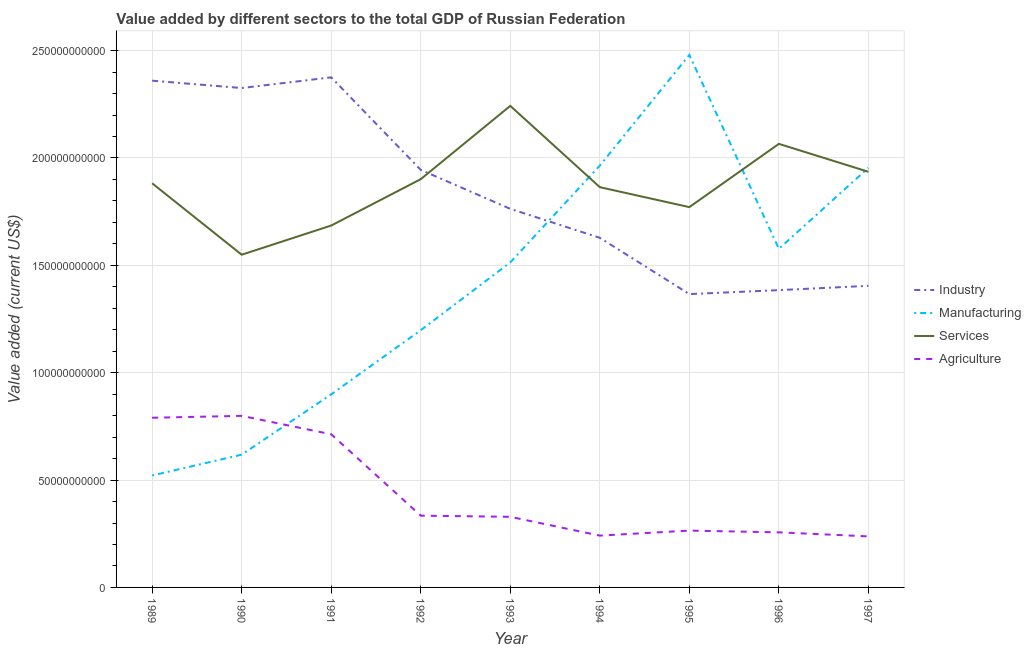Does the line corresponding to value added by services sector intersect with the line corresponding to value added by manufacturing sector?
Offer a terse response. Yes. Is the number of lines equal to the number of legend labels?
Keep it short and to the point. Yes. What is the value added by industrial sector in 1997?
Offer a terse response. 1.40e+11. Across all years, what is the maximum value added by industrial sector?
Your answer should be very brief. 2.38e+11. Across all years, what is the minimum value added by industrial sector?
Your answer should be very brief. 1.37e+11. In which year was the value added by services sector minimum?
Offer a terse response. 1990. What is the total value added by agricultural sector in the graph?
Provide a short and direct response. 3.97e+11. What is the difference between the value added by manufacturing sector in 1992 and that in 1997?
Offer a very short reply. -7.56e+1. What is the difference between the value added by agricultural sector in 1991 and the value added by manufacturing sector in 1994?
Your answer should be compact. -1.25e+11. What is the average value added by industrial sector per year?
Provide a short and direct response. 1.84e+11. In the year 1995, what is the difference between the value added by manufacturing sector and value added by agricultural sector?
Make the answer very short. 2.22e+11. In how many years, is the value added by services sector greater than 220000000000 US$?
Provide a succinct answer. 1. What is the ratio of the value added by manufacturing sector in 1989 to that in 1996?
Offer a terse response. 0.33. What is the difference between the highest and the second highest value added by industrial sector?
Keep it short and to the point. 1.55e+09. What is the difference between the highest and the lowest value added by agricultural sector?
Ensure brevity in your answer.  5.61e+1. Is it the case that in every year, the sum of the value added by agricultural sector and value added by services sector is greater than the sum of value added by manufacturing sector and value added by industrial sector?
Your answer should be very brief. No. Does the value added by industrial sector monotonically increase over the years?
Your response must be concise. No. Is the value added by manufacturing sector strictly less than the value added by agricultural sector over the years?
Give a very brief answer. No. How many lines are there?
Keep it short and to the point. 4. Are the values on the major ticks of Y-axis written in scientific E-notation?
Provide a succinct answer. No. Does the graph contain any zero values?
Keep it short and to the point. No. Where does the legend appear in the graph?
Provide a short and direct response. Center right. How many legend labels are there?
Make the answer very short. 4. How are the legend labels stacked?
Give a very brief answer. Vertical. What is the title of the graph?
Provide a short and direct response. Value added by different sectors to the total GDP of Russian Federation. What is the label or title of the X-axis?
Your answer should be very brief. Year. What is the label or title of the Y-axis?
Keep it short and to the point. Value added (current US$). What is the Value added (current US$) in Industry in 1989?
Provide a short and direct response. 2.36e+11. What is the Value added (current US$) in Manufacturing in 1989?
Keep it short and to the point. 5.21e+1. What is the Value added (current US$) of Services in 1989?
Provide a succinct answer. 1.88e+11. What is the Value added (current US$) in Agriculture in 1989?
Your answer should be compact. 7.90e+1. What is the Value added (current US$) in Industry in 1990?
Give a very brief answer. 2.33e+11. What is the Value added (current US$) of Manufacturing in 1990?
Your answer should be compact. 6.18e+1. What is the Value added (current US$) in Services in 1990?
Your response must be concise. 1.55e+11. What is the Value added (current US$) in Agriculture in 1990?
Give a very brief answer. 7.99e+1. What is the Value added (current US$) of Industry in 1991?
Offer a terse response. 2.38e+11. What is the Value added (current US$) in Manufacturing in 1991?
Your response must be concise. 8.99e+1. What is the Value added (current US$) in Services in 1991?
Keep it short and to the point. 1.69e+11. What is the Value added (current US$) in Agriculture in 1991?
Make the answer very short. 7.13e+1. What is the Value added (current US$) in Industry in 1992?
Ensure brevity in your answer.  1.94e+11. What is the Value added (current US$) in Manufacturing in 1992?
Your response must be concise. 1.20e+11. What is the Value added (current US$) of Services in 1992?
Offer a terse response. 1.90e+11. What is the Value added (current US$) of Agriculture in 1992?
Keep it short and to the point. 3.34e+1. What is the Value added (current US$) in Industry in 1993?
Your answer should be very brief. 1.76e+11. What is the Value added (current US$) of Manufacturing in 1993?
Keep it short and to the point. 1.51e+11. What is the Value added (current US$) of Services in 1993?
Your response must be concise. 2.24e+11. What is the Value added (current US$) of Agriculture in 1993?
Make the answer very short. 3.29e+1. What is the Value added (current US$) in Industry in 1994?
Your answer should be very brief. 1.63e+11. What is the Value added (current US$) of Manufacturing in 1994?
Provide a succinct answer. 1.96e+11. What is the Value added (current US$) of Services in 1994?
Provide a short and direct response. 1.86e+11. What is the Value added (current US$) of Agriculture in 1994?
Your answer should be compact. 2.41e+1. What is the Value added (current US$) in Industry in 1995?
Ensure brevity in your answer.  1.37e+11. What is the Value added (current US$) of Manufacturing in 1995?
Your answer should be very brief. 2.48e+11. What is the Value added (current US$) in Services in 1995?
Offer a very short reply. 1.77e+11. What is the Value added (current US$) of Agriculture in 1995?
Your response must be concise. 2.65e+1. What is the Value added (current US$) of Industry in 1996?
Your answer should be compact. 1.38e+11. What is the Value added (current US$) in Manufacturing in 1996?
Keep it short and to the point. 1.58e+11. What is the Value added (current US$) of Services in 1996?
Your answer should be very brief. 2.07e+11. What is the Value added (current US$) in Agriculture in 1996?
Give a very brief answer. 2.57e+1. What is the Value added (current US$) of Industry in 1997?
Offer a very short reply. 1.40e+11. What is the Value added (current US$) in Manufacturing in 1997?
Your answer should be compact. 1.95e+11. What is the Value added (current US$) in Services in 1997?
Give a very brief answer. 1.94e+11. What is the Value added (current US$) of Agriculture in 1997?
Offer a terse response. 2.38e+1. Across all years, what is the maximum Value added (current US$) in Industry?
Keep it short and to the point. 2.38e+11. Across all years, what is the maximum Value added (current US$) of Manufacturing?
Your answer should be very brief. 2.48e+11. Across all years, what is the maximum Value added (current US$) in Services?
Make the answer very short. 2.24e+11. Across all years, what is the maximum Value added (current US$) of Agriculture?
Offer a terse response. 7.99e+1. Across all years, what is the minimum Value added (current US$) in Industry?
Offer a very short reply. 1.37e+11. Across all years, what is the minimum Value added (current US$) in Manufacturing?
Provide a succinct answer. 5.21e+1. Across all years, what is the minimum Value added (current US$) of Services?
Offer a terse response. 1.55e+11. Across all years, what is the minimum Value added (current US$) in Agriculture?
Your answer should be compact. 2.38e+1. What is the total Value added (current US$) of Industry in the graph?
Give a very brief answer. 1.66e+12. What is the total Value added (current US$) of Manufacturing in the graph?
Provide a short and direct response. 1.27e+12. What is the total Value added (current US$) in Services in the graph?
Your answer should be very brief. 1.69e+12. What is the total Value added (current US$) in Agriculture in the graph?
Give a very brief answer. 3.97e+11. What is the difference between the Value added (current US$) of Industry in 1989 and that in 1990?
Make the answer very short. 3.43e+09. What is the difference between the Value added (current US$) in Manufacturing in 1989 and that in 1990?
Provide a short and direct response. -9.70e+09. What is the difference between the Value added (current US$) in Services in 1989 and that in 1990?
Give a very brief answer. 3.33e+1. What is the difference between the Value added (current US$) in Agriculture in 1989 and that in 1990?
Offer a terse response. -8.80e+08. What is the difference between the Value added (current US$) of Industry in 1989 and that in 1991?
Give a very brief answer. -1.55e+09. What is the difference between the Value added (current US$) of Manufacturing in 1989 and that in 1991?
Offer a terse response. -3.78e+1. What is the difference between the Value added (current US$) of Services in 1989 and that in 1991?
Offer a terse response. 1.97e+1. What is the difference between the Value added (current US$) in Agriculture in 1989 and that in 1991?
Ensure brevity in your answer.  7.69e+09. What is the difference between the Value added (current US$) in Industry in 1989 and that in 1992?
Your answer should be very brief. 4.15e+1. What is the difference between the Value added (current US$) in Manufacturing in 1989 and that in 1992?
Give a very brief answer. -6.77e+1. What is the difference between the Value added (current US$) of Services in 1989 and that in 1992?
Offer a terse response. -1.91e+09. What is the difference between the Value added (current US$) of Agriculture in 1989 and that in 1992?
Keep it short and to the point. 4.56e+1. What is the difference between the Value added (current US$) of Industry in 1989 and that in 1993?
Your response must be concise. 5.97e+1. What is the difference between the Value added (current US$) in Manufacturing in 1989 and that in 1993?
Keep it short and to the point. -9.92e+1. What is the difference between the Value added (current US$) of Services in 1989 and that in 1993?
Provide a succinct answer. -3.61e+1. What is the difference between the Value added (current US$) in Agriculture in 1989 and that in 1993?
Provide a short and direct response. 4.61e+1. What is the difference between the Value added (current US$) in Industry in 1989 and that in 1994?
Provide a succinct answer. 7.32e+1. What is the difference between the Value added (current US$) of Manufacturing in 1989 and that in 1994?
Offer a very short reply. -1.44e+11. What is the difference between the Value added (current US$) of Services in 1989 and that in 1994?
Give a very brief answer. 1.81e+09. What is the difference between the Value added (current US$) in Agriculture in 1989 and that in 1994?
Offer a terse response. 5.49e+1. What is the difference between the Value added (current US$) of Industry in 1989 and that in 1995?
Your answer should be very brief. 9.94e+1. What is the difference between the Value added (current US$) of Manufacturing in 1989 and that in 1995?
Provide a succinct answer. -1.96e+11. What is the difference between the Value added (current US$) in Services in 1989 and that in 1995?
Provide a short and direct response. 1.11e+1. What is the difference between the Value added (current US$) of Agriculture in 1989 and that in 1995?
Offer a terse response. 5.26e+1. What is the difference between the Value added (current US$) in Industry in 1989 and that in 1996?
Ensure brevity in your answer.  9.76e+1. What is the difference between the Value added (current US$) in Manufacturing in 1989 and that in 1996?
Provide a succinct answer. -1.06e+11. What is the difference between the Value added (current US$) in Services in 1989 and that in 1996?
Ensure brevity in your answer.  -1.84e+1. What is the difference between the Value added (current US$) of Agriculture in 1989 and that in 1996?
Your response must be concise. 5.34e+1. What is the difference between the Value added (current US$) of Industry in 1989 and that in 1997?
Your response must be concise. 9.55e+1. What is the difference between the Value added (current US$) in Manufacturing in 1989 and that in 1997?
Your answer should be very brief. -1.43e+11. What is the difference between the Value added (current US$) of Services in 1989 and that in 1997?
Your answer should be compact. -5.35e+09. What is the difference between the Value added (current US$) of Agriculture in 1989 and that in 1997?
Provide a succinct answer. 5.53e+1. What is the difference between the Value added (current US$) of Industry in 1990 and that in 1991?
Offer a very short reply. -4.98e+09. What is the difference between the Value added (current US$) in Manufacturing in 1990 and that in 1991?
Offer a terse response. -2.81e+1. What is the difference between the Value added (current US$) in Services in 1990 and that in 1991?
Offer a terse response. -1.36e+1. What is the difference between the Value added (current US$) of Agriculture in 1990 and that in 1991?
Keep it short and to the point. 8.57e+09. What is the difference between the Value added (current US$) in Industry in 1990 and that in 1992?
Make the answer very short. 3.81e+1. What is the difference between the Value added (current US$) in Manufacturing in 1990 and that in 1992?
Provide a short and direct response. -5.80e+1. What is the difference between the Value added (current US$) in Services in 1990 and that in 1992?
Make the answer very short. -3.52e+1. What is the difference between the Value added (current US$) of Agriculture in 1990 and that in 1992?
Ensure brevity in your answer.  4.65e+1. What is the difference between the Value added (current US$) in Industry in 1990 and that in 1993?
Make the answer very short. 5.63e+1. What is the difference between the Value added (current US$) in Manufacturing in 1990 and that in 1993?
Make the answer very short. -8.95e+1. What is the difference between the Value added (current US$) of Services in 1990 and that in 1993?
Make the answer very short. -6.93e+1. What is the difference between the Value added (current US$) in Agriculture in 1990 and that in 1993?
Keep it short and to the point. 4.70e+1. What is the difference between the Value added (current US$) of Industry in 1990 and that in 1994?
Make the answer very short. 6.98e+1. What is the difference between the Value added (current US$) of Manufacturing in 1990 and that in 1994?
Provide a succinct answer. -1.35e+11. What is the difference between the Value added (current US$) in Services in 1990 and that in 1994?
Provide a succinct answer. -3.15e+1. What is the difference between the Value added (current US$) of Agriculture in 1990 and that in 1994?
Your answer should be compact. 5.58e+1. What is the difference between the Value added (current US$) of Industry in 1990 and that in 1995?
Provide a succinct answer. 9.60e+1. What is the difference between the Value added (current US$) in Manufacturing in 1990 and that in 1995?
Give a very brief answer. -1.86e+11. What is the difference between the Value added (current US$) of Services in 1990 and that in 1995?
Make the answer very short. -2.22e+1. What is the difference between the Value added (current US$) of Agriculture in 1990 and that in 1995?
Your answer should be very brief. 5.34e+1. What is the difference between the Value added (current US$) in Industry in 1990 and that in 1996?
Make the answer very short. 9.41e+1. What is the difference between the Value added (current US$) in Manufacturing in 1990 and that in 1996?
Your answer should be compact. -9.59e+1. What is the difference between the Value added (current US$) of Services in 1990 and that in 1996?
Ensure brevity in your answer.  -5.16e+1. What is the difference between the Value added (current US$) of Agriculture in 1990 and that in 1996?
Your response must be concise. 5.42e+1. What is the difference between the Value added (current US$) in Industry in 1990 and that in 1997?
Your answer should be very brief. 9.21e+1. What is the difference between the Value added (current US$) in Manufacturing in 1990 and that in 1997?
Keep it short and to the point. -1.34e+11. What is the difference between the Value added (current US$) in Services in 1990 and that in 1997?
Your answer should be compact. -3.86e+1. What is the difference between the Value added (current US$) in Agriculture in 1990 and that in 1997?
Make the answer very short. 5.61e+1. What is the difference between the Value added (current US$) of Industry in 1991 and that in 1992?
Ensure brevity in your answer.  4.31e+1. What is the difference between the Value added (current US$) of Manufacturing in 1991 and that in 1992?
Ensure brevity in your answer.  -2.99e+1. What is the difference between the Value added (current US$) of Services in 1991 and that in 1992?
Offer a terse response. -2.16e+1. What is the difference between the Value added (current US$) in Agriculture in 1991 and that in 1992?
Provide a succinct answer. 3.79e+1. What is the difference between the Value added (current US$) of Industry in 1991 and that in 1993?
Offer a terse response. 6.12e+1. What is the difference between the Value added (current US$) in Manufacturing in 1991 and that in 1993?
Give a very brief answer. -6.14e+1. What is the difference between the Value added (current US$) of Services in 1991 and that in 1993?
Provide a short and direct response. -5.57e+1. What is the difference between the Value added (current US$) in Agriculture in 1991 and that in 1993?
Offer a terse response. 3.85e+1. What is the difference between the Value added (current US$) in Industry in 1991 and that in 1994?
Give a very brief answer. 7.47e+1. What is the difference between the Value added (current US$) of Manufacturing in 1991 and that in 1994?
Ensure brevity in your answer.  -1.07e+11. What is the difference between the Value added (current US$) of Services in 1991 and that in 1994?
Your response must be concise. -1.79e+1. What is the difference between the Value added (current US$) in Agriculture in 1991 and that in 1994?
Offer a terse response. 4.72e+1. What is the difference between the Value added (current US$) of Industry in 1991 and that in 1995?
Your answer should be very brief. 1.01e+11. What is the difference between the Value added (current US$) in Manufacturing in 1991 and that in 1995?
Your answer should be very brief. -1.58e+11. What is the difference between the Value added (current US$) of Services in 1991 and that in 1995?
Your answer should be compact. -8.58e+09. What is the difference between the Value added (current US$) in Agriculture in 1991 and that in 1995?
Provide a short and direct response. 4.49e+1. What is the difference between the Value added (current US$) in Industry in 1991 and that in 1996?
Your answer should be compact. 9.91e+1. What is the difference between the Value added (current US$) of Manufacturing in 1991 and that in 1996?
Make the answer very short. -6.78e+1. What is the difference between the Value added (current US$) in Services in 1991 and that in 1996?
Offer a very short reply. -3.80e+1. What is the difference between the Value added (current US$) of Agriculture in 1991 and that in 1996?
Offer a terse response. 4.57e+1. What is the difference between the Value added (current US$) in Industry in 1991 and that in 1997?
Keep it short and to the point. 9.71e+1. What is the difference between the Value added (current US$) in Manufacturing in 1991 and that in 1997?
Your answer should be very brief. -1.05e+11. What is the difference between the Value added (current US$) of Services in 1991 and that in 1997?
Your answer should be compact. -2.50e+1. What is the difference between the Value added (current US$) in Agriculture in 1991 and that in 1997?
Your answer should be very brief. 4.76e+1. What is the difference between the Value added (current US$) in Industry in 1992 and that in 1993?
Offer a very short reply. 1.82e+1. What is the difference between the Value added (current US$) in Manufacturing in 1992 and that in 1993?
Make the answer very short. -3.16e+1. What is the difference between the Value added (current US$) in Services in 1992 and that in 1993?
Give a very brief answer. -3.41e+1. What is the difference between the Value added (current US$) in Agriculture in 1992 and that in 1993?
Your answer should be compact. 5.52e+08. What is the difference between the Value added (current US$) of Industry in 1992 and that in 1994?
Your answer should be very brief. 3.16e+1. What is the difference between the Value added (current US$) of Manufacturing in 1992 and that in 1994?
Provide a short and direct response. -7.66e+1. What is the difference between the Value added (current US$) in Services in 1992 and that in 1994?
Offer a very short reply. 3.72e+09. What is the difference between the Value added (current US$) of Agriculture in 1992 and that in 1994?
Give a very brief answer. 9.30e+09. What is the difference between the Value added (current US$) in Industry in 1992 and that in 1995?
Provide a short and direct response. 5.79e+1. What is the difference between the Value added (current US$) of Manufacturing in 1992 and that in 1995?
Your answer should be very brief. -1.28e+11. What is the difference between the Value added (current US$) of Services in 1992 and that in 1995?
Offer a terse response. 1.30e+1. What is the difference between the Value added (current US$) of Agriculture in 1992 and that in 1995?
Ensure brevity in your answer.  6.96e+09. What is the difference between the Value added (current US$) of Industry in 1992 and that in 1996?
Ensure brevity in your answer.  5.60e+1. What is the difference between the Value added (current US$) of Manufacturing in 1992 and that in 1996?
Your response must be concise. -3.79e+1. What is the difference between the Value added (current US$) of Services in 1992 and that in 1996?
Your answer should be very brief. -1.64e+1. What is the difference between the Value added (current US$) of Agriculture in 1992 and that in 1996?
Make the answer very short. 7.78e+09. What is the difference between the Value added (current US$) in Industry in 1992 and that in 1997?
Your response must be concise. 5.40e+1. What is the difference between the Value added (current US$) of Manufacturing in 1992 and that in 1997?
Your answer should be very brief. -7.56e+1. What is the difference between the Value added (current US$) in Services in 1992 and that in 1997?
Offer a very short reply. -3.44e+09. What is the difference between the Value added (current US$) of Agriculture in 1992 and that in 1997?
Give a very brief answer. 9.66e+09. What is the difference between the Value added (current US$) in Industry in 1993 and that in 1994?
Your answer should be very brief. 1.35e+1. What is the difference between the Value added (current US$) of Manufacturing in 1993 and that in 1994?
Ensure brevity in your answer.  -4.51e+1. What is the difference between the Value added (current US$) of Services in 1993 and that in 1994?
Make the answer very short. 3.79e+1. What is the difference between the Value added (current US$) of Agriculture in 1993 and that in 1994?
Your response must be concise. 8.74e+09. What is the difference between the Value added (current US$) of Industry in 1993 and that in 1995?
Your answer should be very brief. 3.97e+1. What is the difference between the Value added (current US$) of Manufacturing in 1993 and that in 1995?
Keep it short and to the point. -9.66e+1. What is the difference between the Value added (current US$) in Services in 1993 and that in 1995?
Provide a succinct answer. 4.72e+1. What is the difference between the Value added (current US$) of Agriculture in 1993 and that in 1995?
Provide a short and direct response. 6.41e+09. What is the difference between the Value added (current US$) of Industry in 1993 and that in 1996?
Keep it short and to the point. 3.79e+1. What is the difference between the Value added (current US$) in Manufacturing in 1993 and that in 1996?
Offer a very short reply. -6.32e+09. What is the difference between the Value added (current US$) of Services in 1993 and that in 1996?
Your answer should be very brief. 1.77e+1. What is the difference between the Value added (current US$) of Agriculture in 1993 and that in 1996?
Ensure brevity in your answer.  7.22e+09. What is the difference between the Value added (current US$) of Industry in 1993 and that in 1997?
Provide a short and direct response. 3.59e+1. What is the difference between the Value added (current US$) of Manufacturing in 1993 and that in 1997?
Make the answer very short. -4.41e+1. What is the difference between the Value added (current US$) in Services in 1993 and that in 1997?
Provide a short and direct response. 3.07e+1. What is the difference between the Value added (current US$) in Agriculture in 1993 and that in 1997?
Your answer should be compact. 9.11e+09. What is the difference between the Value added (current US$) of Industry in 1994 and that in 1995?
Offer a terse response. 2.62e+1. What is the difference between the Value added (current US$) in Manufacturing in 1994 and that in 1995?
Provide a succinct answer. -5.16e+1. What is the difference between the Value added (current US$) in Services in 1994 and that in 1995?
Offer a terse response. 9.29e+09. What is the difference between the Value added (current US$) of Agriculture in 1994 and that in 1995?
Make the answer very short. -2.33e+09. What is the difference between the Value added (current US$) of Industry in 1994 and that in 1996?
Provide a short and direct response. 2.44e+1. What is the difference between the Value added (current US$) of Manufacturing in 1994 and that in 1996?
Provide a succinct answer. 3.87e+1. What is the difference between the Value added (current US$) in Services in 1994 and that in 1996?
Your answer should be very brief. -2.02e+1. What is the difference between the Value added (current US$) of Agriculture in 1994 and that in 1996?
Your answer should be compact. -1.52e+09. What is the difference between the Value added (current US$) in Industry in 1994 and that in 1997?
Offer a very short reply. 2.24e+1. What is the difference between the Value added (current US$) in Manufacturing in 1994 and that in 1997?
Provide a succinct answer. 1.02e+09. What is the difference between the Value added (current US$) of Services in 1994 and that in 1997?
Offer a terse response. -7.16e+09. What is the difference between the Value added (current US$) in Agriculture in 1994 and that in 1997?
Your answer should be very brief. 3.69e+08. What is the difference between the Value added (current US$) of Industry in 1995 and that in 1996?
Provide a succinct answer. -1.85e+09. What is the difference between the Value added (current US$) of Manufacturing in 1995 and that in 1996?
Provide a succinct answer. 9.03e+1. What is the difference between the Value added (current US$) in Services in 1995 and that in 1996?
Your response must be concise. -2.95e+1. What is the difference between the Value added (current US$) in Agriculture in 1995 and that in 1996?
Keep it short and to the point. 8.15e+08. What is the difference between the Value added (current US$) of Industry in 1995 and that in 1997?
Offer a very short reply. -3.85e+09. What is the difference between the Value added (current US$) of Manufacturing in 1995 and that in 1997?
Your response must be concise. 5.26e+1. What is the difference between the Value added (current US$) of Services in 1995 and that in 1997?
Offer a very short reply. -1.65e+1. What is the difference between the Value added (current US$) of Agriculture in 1995 and that in 1997?
Your answer should be compact. 2.70e+09. What is the difference between the Value added (current US$) of Industry in 1996 and that in 1997?
Ensure brevity in your answer.  -2.00e+09. What is the difference between the Value added (current US$) in Manufacturing in 1996 and that in 1997?
Provide a succinct answer. -3.77e+1. What is the difference between the Value added (current US$) of Services in 1996 and that in 1997?
Offer a terse response. 1.30e+1. What is the difference between the Value added (current US$) of Agriculture in 1996 and that in 1997?
Provide a short and direct response. 1.89e+09. What is the difference between the Value added (current US$) in Industry in 1989 and the Value added (current US$) in Manufacturing in 1990?
Make the answer very short. 1.74e+11. What is the difference between the Value added (current US$) in Industry in 1989 and the Value added (current US$) in Services in 1990?
Provide a short and direct response. 8.11e+1. What is the difference between the Value added (current US$) in Industry in 1989 and the Value added (current US$) in Agriculture in 1990?
Offer a terse response. 1.56e+11. What is the difference between the Value added (current US$) in Manufacturing in 1989 and the Value added (current US$) in Services in 1990?
Keep it short and to the point. -1.03e+11. What is the difference between the Value added (current US$) of Manufacturing in 1989 and the Value added (current US$) of Agriculture in 1990?
Provide a succinct answer. -2.78e+1. What is the difference between the Value added (current US$) in Services in 1989 and the Value added (current US$) in Agriculture in 1990?
Offer a very short reply. 1.08e+11. What is the difference between the Value added (current US$) in Industry in 1989 and the Value added (current US$) in Manufacturing in 1991?
Your answer should be compact. 1.46e+11. What is the difference between the Value added (current US$) of Industry in 1989 and the Value added (current US$) of Services in 1991?
Your answer should be compact. 6.75e+1. What is the difference between the Value added (current US$) in Industry in 1989 and the Value added (current US$) in Agriculture in 1991?
Make the answer very short. 1.65e+11. What is the difference between the Value added (current US$) of Manufacturing in 1989 and the Value added (current US$) of Services in 1991?
Your answer should be very brief. -1.16e+11. What is the difference between the Value added (current US$) in Manufacturing in 1989 and the Value added (current US$) in Agriculture in 1991?
Provide a short and direct response. -1.92e+1. What is the difference between the Value added (current US$) of Services in 1989 and the Value added (current US$) of Agriculture in 1991?
Offer a terse response. 1.17e+11. What is the difference between the Value added (current US$) in Industry in 1989 and the Value added (current US$) in Manufacturing in 1992?
Offer a terse response. 1.16e+11. What is the difference between the Value added (current US$) in Industry in 1989 and the Value added (current US$) in Services in 1992?
Offer a terse response. 4.59e+1. What is the difference between the Value added (current US$) of Industry in 1989 and the Value added (current US$) of Agriculture in 1992?
Give a very brief answer. 2.03e+11. What is the difference between the Value added (current US$) in Manufacturing in 1989 and the Value added (current US$) in Services in 1992?
Your answer should be very brief. -1.38e+11. What is the difference between the Value added (current US$) of Manufacturing in 1989 and the Value added (current US$) of Agriculture in 1992?
Your answer should be very brief. 1.87e+1. What is the difference between the Value added (current US$) of Services in 1989 and the Value added (current US$) of Agriculture in 1992?
Provide a short and direct response. 1.55e+11. What is the difference between the Value added (current US$) in Industry in 1989 and the Value added (current US$) in Manufacturing in 1993?
Your answer should be very brief. 8.46e+1. What is the difference between the Value added (current US$) of Industry in 1989 and the Value added (current US$) of Services in 1993?
Your answer should be compact. 1.17e+1. What is the difference between the Value added (current US$) in Industry in 1989 and the Value added (current US$) in Agriculture in 1993?
Offer a terse response. 2.03e+11. What is the difference between the Value added (current US$) of Manufacturing in 1989 and the Value added (current US$) of Services in 1993?
Your answer should be very brief. -1.72e+11. What is the difference between the Value added (current US$) in Manufacturing in 1989 and the Value added (current US$) in Agriculture in 1993?
Provide a succinct answer. 1.92e+1. What is the difference between the Value added (current US$) of Services in 1989 and the Value added (current US$) of Agriculture in 1993?
Your response must be concise. 1.55e+11. What is the difference between the Value added (current US$) of Industry in 1989 and the Value added (current US$) of Manufacturing in 1994?
Your answer should be very brief. 3.96e+1. What is the difference between the Value added (current US$) of Industry in 1989 and the Value added (current US$) of Services in 1994?
Your answer should be compact. 4.96e+1. What is the difference between the Value added (current US$) of Industry in 1989 and the Value added (current US$) of Agriculture in 1994?
Provide a short and direct response. 2.12e+11. What is the difference between the Value added (current US$) in Manufacturing in 1989 and the Value added (current US$) in Services in 1994?
Make the answer very short. -1.34e+11. What is the difference between the Value added (current US$) in Manufacturing in 1989 and the Value added (current US$) in Agriculture in 1994?
Provide a short and direct response. 2.80e+1. What is the difference between the Value added (current US$) of Services in 1989 and the Value added (current US$) of Agriculture in 1994?
Provide a short and direct response. 1.64e+11. What is the difference between the Value added (current US$) of Industry in 1989 and the Value added (current US$) of Manufacturing in 1995?
Provide a succinct answer. -1.20e+1. What is the difference between the Value added (current US$) of Industry in 1989 and the Value added (current US$) of Services in 1995?
Offer a very short reply. 5.89e+1. What is the difference between the Value added (current US$) of Industry in 1989 and the Value added (current US$) of Agriculture in 1995?
Make the answer very short. 2.10e+11. What is the difference between the Value added (current US$) in Manufacturing in 1989 and the Value added (current US$) in Services in 1995?
Provide a succinct answer. -1.25e+11. What is the difference between the Value added (current US$) in Manufacturing in 1989 and the Value added (current US$) in Agriculture in 1995?
Offer a very short reply. 2.57e+1. What is the difference between the Value added (current US$) of Services in 1989 and the Value added (current US$) of Agriculture in 1995?
Keep it short and to the point. 1.62e+11. What is the difference between the Value added (current US$) of Industry in 1989 and the Value added (current US$) of Manufacturing in 1996?
Give a very brief answer. 7.83e+1. What is the difference between the Value added (current US$) of Industry in 1989 and the Value added (current US$) of Services in 1996?
Your answer should be compact. 2.94e+1. What is the difference between the Value added (current US$) of Industry in 1989 and the Value added (current US$) of Agriculture in 1996?
Ensure brevity in your answer.  2.10e+11. What is the difference between the Value added (current US$) in Manufacturing in 1989 and the Value added (current US$) in Services in 1996?
Offer a terse response. -1.54e+11. What is the difference between the Value added (current US$) in Manufacturing in 1989 and the Value added (current US$) in Agriculture in 1996?
Offer a terse response. 2.65e+1. What is the difference between the Value added (current US$) in Services in 1989 and the Value added (current US$) in Agriculture in 1996?
Your response must be concise. 1.63e+11. What is the difference between the Value added (current US$) in Industry in 1989 and the Value added (current US$) in Manufacturing in 1997?
Ensure brevity in your answer.  4.06e+1. What is the difference between the Value added (current US$) in Industry in 1989 and the Value added (current US$) in Services in 1997?
Offer a very short reply. 4.24e+1. What is the difference between the Value added (current US$) of Industry in 1989 and the Value added (current US$) of Agriculture in 1997?
Provide a succinct answer. 2.12e+11. What is the difference between the Value added (current US$) in Manufacturing in 1989 and the Value added (current US$) in Services in 1997?
Your answer should be compact. -1.41e+11. What is the difference between the Value added (current US$) of Manufacturing in 1989 and the Value added (current US$) of Agriculture in 1997?
Provide a short and direct response. 2.84e+1. What is the difference between the Value added (current US$) of Services in 1989 and the Value added (current US$) of Agriculture in 1997?
Offer a terse response. 1.64e+11. What is the difference between the Value added (current US$) in Industry in 1990 and the Value added (current US$) in Manufacturing in 1991?
Give a very brief answer. 1.43e+11. What is the difference between the Value added (current US$) in Industry in 1990 and the Value added (current US$) in Services in 1991?
Ensure brevity in your answer.  6.40e+1. What is the difference between the Value added (current US$) in Industry in 1990 and the Value added (current US$) in Agriculture in 1991?
Provide a succinct answer. 1.61e+11. What is the difference between the Value added (current US$) of Manufacturing in 1990 and the Value added (current US$) of Services in 1991?
Ensure brevity in your answer.  -1.07e+11. What is the difference between the Value added (current US$) in Manufacturing in 1990 and the Value added (current US$) in Agriculture in 1991?
Your answer should be compact. -9.50e+09. What is the difference between the Value added (current US$) in Services in 1990 and the Value added (current US$) in Agriculture in 1991?
Your answer should be compact. 8.36e+1. What is the difference between the Value added (current US$) in Industry in 1990 and the Value added (current US$) in Manufacturing in 1992?
Provide a short and direct response. 1.13e+11. What is the difference between the Value added (current US$) of Industry in 1990 and the Value added (current US$) of Services in 1992?
Make the answer very short. 4.24e+1. What is the difference between the Value added (current US$) of Industry in 1990 and the Value added (current US$) of Agriculture in 1992?
Keep it short and to the point. 1.99e+11. What is the difference between the Value added (current US$) in Manufacturing in 1990 and the Value added (current US$) in Services in 1992?
Keep it short and to the point. -1.28e+11. What is the difference between the Value added (current US$) of Manufacturing in 1990 and the Value added (current US$) of Agriculture in 1992?
Make the answer very short. 2.84e+1. What is the difference between the Value added (current US$) of Services in 1990 and the Value added (current US$) of Agriculture in 1992?
Give a very brief answer. 1.22e+11. What is the difference between the Value added (current US$) of Industry in 1990 and the Value added (current US$) of Manufacturing in 1993?
Offer a terse response. 8.12e+1. What is the difference between the Value added (current US$) in Industry in 1990 and the Value added (current US$) in Services in 1993?
Ensure brevity in your answer.  8.31e+09. What is the difference between the Value added (current US$) of Industry in 1990 and the Value added (current US$) of Agriculture in 1993?
Your response must be concise. 2.00e+11. What is the difference between the Value added (current US$) of Manufacturing in 1990 and the Value added (current US$) of Services in 1993?
Ensure brevity in your answer.  -1.62e+11. What is the difference between the Value added (current US$) of Manufacturing in 1990 and the Value added (current US$) of Agriculture in 1993?
Your answer should be compact. 2.89e+1. What is the difference between the Value added (current US$) in Services in 1990 and the Value added (current US$) in Agriculture in 1993?
Your answer should be compact. 1.22e+11. What is the difference between the Value added (current US$) in Industry in 1990 and the Value added (current US$) in Manufacturing in 1994?
Give a very brief answer. 3.61e+1. What is the difference between the Value added (current US$) in Industry in 1990 and the Value added (current US$) in Services in 1994?
Make the answer very short. 4.62e+1. What is the difference between the Value added (current US$) of Industry in 1990 and the Value added (current US$) of Agriculture in 1994?
Make the answer very short. 2.08e+11. What is the difference between the Value added (current US$) of Manufacturing in 1990 and the Value added (current US$) of Services in 1994?
Your answer should be compact. -1.25e+11. What is the difference between the Value added (current US$) of Manufacturing in 1990 and the Value added (current US$) of Agriculture in 1994?
Your answer should be compact. 3.77e+1. What is the difference between the Value added (current US$) in Services in 1990 and the Value added (current US$) in Agriculture in 1994?
Your answer should be very brief. 1.31e+11. What is the difference between the Value added (current US$) of Industry in 1990 and the Value added (current US$) of Manufacturing in 1995?
Ensure brevity in your answer.  -1.54e+1. What is the difference between the Value added (current US$) of Industry in 1990 and the Value added (current US$) of Services in 1995?
Ensure brevity in your answer.  5.55e+1. What is the difference between the Value added (current US$) in Industry in 1990 and the Value added (current US$) in Agriculture in 1995?
Provide a succinct answer. 2.06e+11. What is the difference between the Value added (current US$) in Manufacturing in 1990 and the Value added (current US$) in Services in 1995?
Your answer should be very brief. -1.15e+11. What is the difference between the Value added (current US$) of Manufacturing in 1990 and the Value added (current US$) of Agriculture in 1995?
Offer a terse response. 3.54e+1. What is the difference between the Value added (current US$) in Services in 1990 and the Value added (current US$) in Agriculture in 1995?
Provide a succinct answer. 1.28e+11. What is the difference between the Value added (current US$) of Industry in 1990 and the Value added (current US$) of Manufacturing in 1996?
Offer a very short reply. 7.49e+1. What is the difference between the Value added (current US$) in Industry in 1990 and the Value added (current US$) in Services in 1996?
Keep it short and to the point. 2.60e+1. What is the difference between the Value added (current US$) in Industry in 1990 and the Value added (current US$) in Agriculture in 1996?
Keep it short and to the point. 2.07e+11. What is the difference between the Value added (current US$) of Manufacturing in 1990 and the Value added (current US$) of Services in 1996?
Give a very brief answer. -1.45e+11. What is the difference between the Value added (current US$) in Manufacturing in 1990 and the Value added (current US$) in Agriculture in 1996?
Provide a succinct answer. 3.62e+1. What is the difference between the Value added (current US$) of Services in 1990 and the Value added (current US$) of Agriculture in 1996?
Make the answer very short. 1.29e+11. What is the difference between the Value added (current US$) in Industry in 1990 and the Value added (current US$) in Manufacturing in 1997?
Your answer should be very brief. 3.72e+1. What is the difference between the Value added (current US$) of Industry in 1990 and the Value added (current US$) of Services in 1997?
Your response must be concise. 3.90e+1. What is the difference between the Value added (current US$) of Industry in 1990 and the Value added (current US$) of Agriculture in 1997?
Provide a succinct answer. 2.09e+11. What is the difference between the Value added (current US$) in Manufacturing in 1990 and the Value added (current US$) in Services in 1997?
Provide a short and direct response. -1.32e+11. What is the difference between the Value added (current US$) of Manufacturing in 1990 and the Value added (current US$) of Agriculture in 1997?
Give a very brief answer. 3.81e+1. What is the difference between the Value added (current US$) in Services in 1990 and the Value added (current US$) in Agriculture in 1997?
Ensure brevity in your answer.  1.31e+11. What is the difference between the Value added (current US$) of Industry in 1991 and the Value added (current US$) of Manufacturing in 1992?
Offer a terse response. 1.18e+11. What is the difference between the Value added (current US$) of Industry in 1991 and the Value added (current US$) of Services in 1992?
Provide a succinct answer. 4.74e+1. What is the difference between the Value added (current US$) of Industry in 1991 and the Value added (current US$) of Agriculture in 1992?
Provide a succinct answer. 2.04e+11. What is the difference between the Value added (current US$) in Manufacturing in 1991 and the Value added (current US$) in Services in 1992?
Keep it short and to the point. -1.00e+11. What is the difference between the Value added (current US$) of Manufacturing in 1991 and the Value added (current US$) of Agriculture in 1992?
Your response must be concise. 5.65e+1. What is the difference between the Value added (current US$) in Services in 1991 and the Value added (current US$) in Agriculture in 1992?
Offer a terse response. 1.35e+11. What is the difference between the Value added (current US$) of Industry in 1991 and the Value added (current US$) of Manufacturing in 1993?
Ensure brevity in your answer.  8.62e+1. What is the difference between the Value added (current US$) of Industry in 1991 and the Value added (current US$) of Services in 1993?
Offer a very short reply. 1.33e+1. What is the difference between the Value added (current US$) in Industry in 1991 and the Value added (current US$) in Agriculture in 1993?
Ensure brevity in your answer.  2.05e+11. What is the difference between the Value added (current US$) of Manufacturing in 1991 and the Value added (current US$) of Services in 1993?
Your answer should be very brief. -1.34e+11. What is the difference between the Value added (current US$) in Manufacturing in 1991 and the Value added (current US$) in Agriculture in 1993?
Give a very brief answer. 5.71e+1. What is the difference between the Value added (current US$) in Services in 1991 and the Value added (current US$) in Agriculture in 1993?
Offer a terse response. 1.36e+11. What is the difference between the Value added (current US$) in Industry in 1991 and the Value added (current US$) in Manufacturing in 1994?
Offer a very short reply. 4.11e+1. What is the difference between the Value added (current US$) in Industry in 1991 and the Value added (current US$) in Services in 1994?
Your answer should be compact. 5.11e+1. What is the difference between the Value added (current US$) in Industry in 1991 and the Value added (current US$) in Agriculture in 1994?
Your answer should be very brief. 2.13e+11. What is the difference between the Value added (current US$) of Manufacturing in 1991 and the Value added (current US$) of Services in 1994?
Provide a succinct answer. -9.65e+1. What is the difference between the Value added (current US$) of Manufacturing in 1991 and the Value added (current US$) of Agriculture in 1994?
Your answer should be very brief. 6.58e+1. What is the difference between the Value added (current US$) in Services in 1991 and the Value added (current US$) in Agriculture in 1994?
Ensure brevity in your answer.  1.44e+11. What is the difference between the Value added (current US$) of Industry in 1991 and the Value added (current US$) of Manufacturing in 1995?
Your response must be concise. -1.05e+1. What is the difference between the Value added (current US$) of Industry in 1991 and the Value added (current US$) of Services in 1995?
Provide a succinct answer. 6.04e+1. What is the difference between the Value added (current US$) in Industry in 1991 and the Value added (current US$) in Agriculture in 1995?
Your answer should be very brief. 2.11e+11. What is the difference between the Value added (current US$) in Manufacturing in 1991 and the Value added (current US$) in Services in 1995?
Your response must be concise. -8.72e+1. What is the difference between the Value added (current US$) of Manufacturing in 1991 and the Value added (current US$) of Agriculture in 1995?
Offer a terse response. 6.35e+1. What is the difference between the Value added (current US$) in Services in 1991 and the Value added (current US$) in Agriculture in 1995?
Give a very brief answer. 1.42e+11. What is the difference between the Value added (current US$) in Industry in 1991 and the Value added (current US$) in Manufacturing in 1996?
Ensure brevity in your answer.  7.99e+1. What is the difference between the Value added (current US$) in Industry in 1991 and the Value added (current US$) in Services in 1996?
Keep it short and to the point. 3.10e+1. What is the difference between the Value added (current US$) in Industry in 1991 and the Value added (current US$) in Agriculture in 1996?
Provide a short and direct response. 2.12e+11. What is the difference between the Value added (current US$) of Manufacturing in 1991 and the Value added (current US$) of Services in 1996?
Keep it short and to the point. -1.17e+11. What is the difference between the Value added (current US$) of Manufacturing in 1991 and the Value added (current US$) of Agriculture in 1996?
Your answer should be very brief. 6.43e+1. What is the difference between the Value added (current US$) in Services in 1991 and the Value added (current US$) in Agriculture in 1996?
Offer a terse response. 1.43e+11. What is the difference between the Value added (current US$) of Industry in 1991 and the Value added (current US$) of Manufacturing in 1997?
Give a very brief answer. 4.21e+1. What is the difference between the Value added (current US$) of Industry in 1991 and the Value added (current US$) of Services in 1997?
Keep it short and to the point. 4.40e+1. What is the difference between the Value added (current US$) in Industry in 1991 and the Value added (current US$) in Agriculture in 1997?
Ensure brevity in your answer.  2.14e+11. What is the difference between the Value added (current US$) in Manufacturing in 1991 and the Value added (current US$) in Services in 1997?
Your answer should be very brief. -1.04e+11. What is the difference between the Value added (current US$) in Manufacturing in 1991 and the Value added (current US$) in Agriculture in 1997?
Ensure brevity in your answer.  6.62e+1. What is the difference between the Value added (current US$) in Services in 1991 and the Value added (current US$) in Agriculture in 1997?
Your response must be concise. 1.45e+11. What is the difference between the Value added (current US$) of Industry in 1992 and the Value added (current US$) of Manufacturing in 1993?
Give a very brief answer. 4.31e+1. What is the difference between the Value added (current US$) in Industry in 1992 and the Value added (current US$) in Services in 1993?
Your response must be concise. -2.98e+1. What is the difference between the Value added (current US$) of Industry in 1992 and the Value added (current US$) of Agriculture in 1993?
Keep it short and to the point. 1.62e+11. What is the difference between the Value added (current US$) of Manufacturing in 1992 and the Value added (current US$) of Services in 1993?
Make the answer very short. -1.04e+11. What is the difference between the Value added (current US$) in Manufacturing in 1992 and the Value added (current US$) in Agriculture in 1993?
Keep it short and to the point. 8.69e+1. What is the difference between the Value added (current US$) of Services in 1992 and the Value added (current US$) of Agriculture in 1993?
Your response must be concise. 1.57e+11. What is the difference between the Value added (current US$) of Industry in 1992 and the Value added (current US$) of Manufacturing in 1994?
Keep it short and to the point. -1.97e+09. What is the difference between the Value added (current US$) in Industry in 1992 and the Value added (current US$) in Services in 1994?
Offer a very short reply. 8.06e+09. What is the difference between the Value added (current US$) in Industry in 1992 and the Value added (current US$) in Agriculture in 1994?
Provide a short and direct response. 1.70e+11. What is the difference between the Value added (current US$) in Manufacturing in 1992 and the Value added (current US$) in Services in 1994?
Offer a very short reply. -6.66e+1. What is the difference between the Value added (current US$) of Manufacturing in 1992 and the Value added (current US$) of Agriculture in 1994?
Make the answer very short. 9.57e+1. What is the difference between the Value added (current US$) in Services in 1992 and the Value added (current US$) in Agriculture in 1994?
Offer a terse response. 1.66e+11. What is the difference between the Value added (current US$) in Industry in 1992 and the Value added (current US$) in Manufacturing in 1995?
Provide a succinct answer. -5.35e+1. What is the difference between the Value added (current US$) in Industry in 1992 and the Value added (current US$) in Services in 1995?
Provide a succinct answer. 1.74e+1. What is the difference between the Value added (current US$) of Industry in 1992 and the Value added (current US$) of Agriculture in 1995?
Provide a short and direct response. 1.68e+11. What is the difference between the Value added (current US$) in Manufacturing in 1992 and the Value added (current US$) in Services in 1995?
Ensure brevity in your answer.  -5.73e+1. What is the difference between the Value added (current US$) of Manufacturing in 1992 and the Value added (current US$) of Agriculture in 1995?
Give a very brief answer. 9.33e+1. What is the difference between the Value added (current US$) in Services in 1992 and the Value added (current US$) in Agriculture in 1995?
Ensure brevity in your answer.  1.64e+11. What is the difference between the Value added (current US$) of Industry in 1992 and the Value added (current US$) of Manufacturing in 1996?
Keep it short and to the point. 3.68e+1. What is the difference between the Value added (current US$) in Industry in 1992 and the Value added (current US$) in Services in 1996?
Your response must be concise. -1.21e+1. What is the difference between the Value added (current US$) in Industry in 1992 and the Value added (current US$) in Agriculture in 1996?
Your answer should be compact. 1.69e+11. What is the difference between the Value added (current US$) in Manufacturing in 1992 and the Value added (current US$) in Services in 1996?
Provide a short and direct response. -8.68e+1. What is the difference between the Value added (current US$) in Manufacturing in 1992 and the Value added (current US$) in Agriculture in 1996?
Your answer should be compact. 9.41e+1. What is the difference between the Value added (current US$) in Services in 1992 and the Value added (current US$) in Agriculture in 1996?
Your response must be concise. 1.64e+11. What is the difference between the Value added (current US$) in Industry in 1992 and the Value added (current US$) in Manufacturing in 1997?
Offer a terse response. -9.51e+08. What is the difference between the Value added (current US$) of Industry in 1992 and the Value added (current US$) of Services in 1997?
Keep it short and to the point. 8.97e+08. What is the difference between the Value added (current US$) in Industry in 1992 and the Value added (current US$) in Agriculture in 1997?
Provide a succinct answer. 1.71e+11. What is the difference between the Value added (current US$) of Manufacturing in 1992 and the Value added (current US$) of Services in 1997?
Give a very brief answer. -7.38e+1. What is the difference between the Value added (current US$) of Manufacturing in 1992 and the Value added (current US$) of Agriculture in 1997?
Your answer should be very brief. 9.60e+1. What is the difference between the Value added (current US$) of Services in 1992 and the Value added (current US$) of Agriculture in 1997?
Provide a succinct answer. 1.66e+11. What is the difference between the Value added (current US$) of Industry in 1993 and the Value added (current US$) of Manufacturing in 1994?
Offer a terse response. -2.01e+1. What is the difference between the Value added (current US$) of Industry in 1993 and the Value added (current US$) of Services in 1994?
Keep it short and to the point. -1.01e+1. What is the difference between the Value added (current US$) in Industry in 1993 and the Value added (current US$) in Agriculture in 1994?
Provide a short and direct response. 1.52e+11. What is the difference between the Value added (current US$) in Manufacturing in 1993 and the Value added (current US$) in Services in 1994?
Offer a terse response. -3.50e+1. What is the difference between the Value added (current US$) in Manufacturing in 1993 and the Value added (current US$) in Agriculture in 1994?
Offer a very short reply. 1.27e+11. What is the difference between the Value added (current US$) in Services in 1993 and the Value added (current US$) in Agriculture in 1994?
Provide a succinct answer. 2.00e+11. What is the difference between the Value added (current US$) of Industry in 1993 and the Value added (current US$) of Manufacturing in 1995?
Offer a very short reply. -7.17e+1. What is the difference between the Value added (current US$) in Industry in 1993 and the Value added (current US$) in Services in 1995?
Provide a succinct answer. -8.04e+08. What is the difference between the Value added (current US$) of Industry in 1993 and the Value added (current US$) of Agriculture in 1995?
Provide a succinct answer. 1.50e+11. What is the difference between the Value added (current US$) of Manufacturing in 1993 and the Value added (current US$) of Services in 1995?
Provide a succinct answer. -2.58e+1. What is the difference between the Value added (current US$) of Manufacturing in 1993 and the Value added (current US$) of Agriculture in 1995?
Make the answer very short. 1.25e+11. What is the difference between the Value added (current US$) in Services in 1993 and the Value added (current US$) in Agriculture in 1995?
Your answer should be compact. 1.98e+11. What is the difference between the Value added (current US$) in Industry in 1993 and the Value added (current US$) in Manufacturing in 1996?
Give a very brief answer. 1.86e+1. What is the difference between the Value added (current US$) of Industry in 1993 and the Value added (current US$) of Services in 1996?
Give a very brief answer. -3.03e+1. What is the difference between the Value added (current US$) of Industry in 1993 and the Value added (current US$) of Agriculture in 1996?
Your answer should be compact. 1.51e+11. What is the difference between the Value added (current US$) of Manufacturing in 1993 and the Value added (current US$) of Services in 1996?
Offer a terse response. -5.52e+1. What is the difference between the Value added (current US$) of Manufacturing in 1993 and the Value added (current US$) of Agriculture in 1996?
Keep it short and to the point. 1.26e+11. What is the difference between the Value added (current US$) of Services in 1993 and the Value added (current US$) of Agriculture in 1996?
Give a very brief answer. 1.99e+11. What is the difference between the Value added (current US$) of Industry in 1993 and the Value added (current US$) of Manufacturing in 1997?
Offer a very short reply. -1.91e+1. What is the difference between the Value added (current US$) of Industry in 1993 and the Value added (current US$) of Services in 1997?
Your answer should be very brief. -1.73e+1. What is the difference between the Value added (current US$) in Industry in 1993 and the Value added (current US$) in Agriculture in 1997?
Your answer should be compact. 1.53e+11. What is the difference between the Value added (current US$) in Manufacturing in 1993 and the Value added (current US$) in Services in 1997?
Provide a succinct answer. -4.22e+1. What is the difference between the Value added (current US$) in Manufacturing in 1993 and the Value added (current US$) in Agriculture in 1997?
Make the answer very short. 1.28e+11. What is the difference between the Value added (current US$) of Services in 1993 and the Value added (current US$) of Agriculture in 1997?
Provide a short and direct response. 2.01e+11. What is the difference between the Value added (current US$) in Industry in 1994 and the Value added (current US$) in Manufacturing in 1995?
Give a very brief answer. -8.52e+1. What is the difference between the Value added (current US$) in Industry in 1994 and the Value added (current US$) in Services in 1995?
Your response must be concise. -1.43e+1. What is the difference between the Value added (current US$) of Industry in 1994 and the Value added (current US$) of Agriculture in 1995?
Your answer should be compact. 1.36e+11. What is the difference between the Value added (current US$) in Manufacturing in 1994 and the Value added (current US$) in Services in 1995?
Provide a short and direct response. 1.93e+1. What is the difference between the Value added (current US$) in Manufacturing in 1994 and the Value added (current US$) in Agriculture in 1995?
Ensure brevity in your answer.  1.70e+11. What is the difference between the Value added (current US$) of Services in 1994 and the Value added (current US$) of Agriculture in 1995?
Ensure brevity in your answer.  1.60e+11. What is the difference between the Value added (current US$) in Industry in 1994 and the Value added (current US$) in Manufacturing in 1996?
Provide a succinct answer. 5.14e+09. What is the difference between the Value added (current US$) of Industry in 1994 and the Value added (current US$) of Services in 1996?
Your answer should be very brief. -4.38e+1. What is the difference between the Value added (current US$) of Industry in 1994 and the Value added (current US$) of Agriculture in 1996?
Give a very brief answer. 1.37e+11. What is the difference between the Value added (current US$) in Manufacturing in 1994 and the Value added (current US$) in Services in 1996?
Your response must be concise. -1.01e+1. What is the difference between the Value added (current US$) of Manufacturing in 1994 and the Value added (current US$) of Agriculture in 1996?
Your answer should be very brief. 1.71e+11. What is the difference between the Value added (current US$) in Services in 1994 and the Value added (current US$) in Agriculture in 1996?
Give a very brief answer. 1.61e+11. What is the difference between the Value added (current US$) in Industry in 1994 and the Value added (current US$) in Manufacturing in 1997?
Your response must be concise. -3.26e+1. What is the difference between the Value added (current US$) of Industry in 1994 and the Value added (current US$) of Services in 1997?
Offer a very short reply. -3.07e+1. What is the difference between the Value added (current US$) of Industry in 1994 and the Value added (current US$) of Agriculture in 1997?
Ensure brevity in your answer.  1.39e+11. What is the difference between the Value added (current US$) of Manufacturing in 1994 and the Value added (current US$) of Services in 1997?
Provide a succinct answer. 2.87e+09. What is the difference between the Value added (current US$) of Manufacturing in 1994 and the Value added (current US$) of Agriculture in 1997?
Offer a very short reply. 1.73e+11. What is the difference between the Value added (current US$) in Services in 1994 and the Value added (current US$) in Agriculture in 1997?
Offer a very short reply. 1.63e+11. What is the difference between the Value added (current US$) of Industry in 1995 and the Value added (current US$) of Manufacturing in 1996?
Ensure brevity in your answer.  -2.11e+1. What is the difference between the Value added (current US$) of Industry in 1995 and the Value added (current US$) of Services in 1996?
Your answer should be compact. -7.00e+1. What is the difference between the Value added (current US$) of Industry in 1995 and the Value added (current US$) of Agriculture in 1996?
Offer a terse response. 1.11e+11. What is the difference between the Value added (current US$) of Manufacturing in 1995 and the Value added (current US$) of Services in 1996?
Make the answer very short. 4.14e+1. What is the difference between the Value added (current US$) of Manufacturing in 1995 and the Value added (current US$) of Agriculture in 1996?
Your response must be concise. 2.22e+11. What is the difference between the Value added (current US$) in Services in 1995 and the Value added (current US$) in Agriculture in 1996?
Offer a very short reply. 1.51e+11. What is the difference between the Value added (current US$) in Industry in 1995 and the Value added (current US$) in Manufacturing in 1997?
Keep it short and to the point. -5.88e+1. What is the difference between the Value added (current US$) of Industry in 1995 and the Value added (current US$) of Services in 1997?
Provide a short and direct response. -5.70e+1. What is the difference between the Value added (current US$) in Industry in 1995 and the Value added (current US$) in Agriculture in 1997?
Provide a short and direct response. 1.13e+11. What is the difference between the Value added (current US$) of Manufacturing in 1995 and the Value added (current US$) of Services in 1997?
Make the answer very short. 5.44e+1. What is the difference between the Value added (current US$) in Manufacturing in 1995 and the Value added (current US$) in Agriculture in 1997?
Your answer should be very brief. 2.24e+11. What is the difference between the Value added (current US$) in Services in 1995 and the Value added (current US$) in Agriculture in 1997?
Offer a terse response. 1.53e+11. What is the difference between the Value added (current US$) of Industry in 1996 and the Value added (current US$) of Manufacturing in 1997?
Your response must be concise. -5.70e+1. What is the difference between the Value added (current US$) in Industry in 1996 and the Value added (current US$) in Services in 1997?
Offer a very short reply. -5.51e+1. What is the difference between the Value added (current US$) in Industry in 1996 and the Value added (current US$) in Agriculture in 1997?
Give a very brief answer. 1.15e+11. What is the difference between the Value added (current US$) of Manufacturing in 1996 and the Value added (current US$) of Services in 1997?
Your answer should be very brief. -3.59e+1. What is the difference between the Value added (current US$) of Manufacturing in 1996 and the Value added (current US$) of Agriculture in 1997?
Provide a succinct answer. 1.34e+11. What is the difference between the Value added (current US$) in Services in 1996 and the Value added (current US$) in Agriculture in 1997?
Your response must be concise. 1.83e+11. What is the average Value added (current US$) in Industry per year?
Provide a succinct answer. 1.84e+11. What is the average Value added (current US$) in Manufacturing per year?
Make the answer very short. 1.41e+11. What is the average Value added (current US$) in Services per year?
Provide a short and direct response. 1.88e+11. What is the average Value added (current US$) of Agriculture per year?
Keep it short and to the point. 4.41e+1. In the year 1989, what is the difference between the Value added (current US$) in Industry and Value added (current US$) in Manufacturing?
Your response must be concise. 1.84e+11. In the year 1989, what is the difference between the Value added (current US$) of Industry and Value added (current US$) of Services?
Your answer should be compact. 4.78e+1. In the year 1989, what is the difference between the Value added (current US$) of Industry and Value added (current US$) of Agriculture?
Your answer should be very brief. 1.57e+11. In the year 1989, what is the difference between the Value added (current US$) of Manufacturing and Value added (current US$) of Services?
Ensure brevity in your answer.  -1.36e+11. In the year 1989, what is the difference between the Value added (current US$) of Manufacturing and Value added (current US$) of Agriculture?
Provide a succinct answer. -2.69e+1. In the year 1989, what is the difference between the Value added (current US$) of Services and Value added (current US$) of Agriculture?
Make the answer very short. 1.09e+11. In the year 1990, what is the difference between the Value added (current US$) of Industry and Value added (current US$) of Manufacturing?
Provide a short and direct response. 1.71e+11. In the year 1990, what is the difference between the Value added (current US$) in Industry and Value added (current US$) in Services?
Give a very brief answer. 7.76e+1. In the year 1990, what is the difference between the Value added (current US$) of Industry and Value added (current US$) of Agriculture?
Your answer should be very brief. 1.53e+11. In the year 1990, what is the difference between the Value added (current US$) in Manufacturing and Value added (current US$) in Services?
Give a very brief answer. -9.31e+1. In the year 1990, what is the difference between the Value added (current US$) in Manufacturing and Value added (current US$) in Agriculture?
Keep it short and to the point. -1.81e+1. In the year 1990, what is the difference between the Value added (current US$) in Services and Value added (current US$) in Agriculture?
Give a very brief answer. 7.51e+1. In the year 1991, what is the difference between the Value added (current US$) of Industry and Value added (current US$) of Manufacturing?
Make the answer very short. 1.48e+11. In the year 1991, what is the difference between the Value added (current US$) of Industry and Value added (current US$) of Services?
Offer a terse response. 6.90e+1. In the year 1991, what is the difference between the Value added (current US$) in Industry and Value added (current US$) in Agriculture?
Your answer should be compact. 1.66e+11. In the year 1991, what is the difference between the Value added (current US$) in Manufacturing and Value added (current US$) in Services?
Your answer should be very brief. -7.86e+1. In the year 1991, what is the difference between the Value added (current US$) in Manufacturing and Value added (current US$) in Agriculture?
Offer a terse response. 1.86e+1. In the year 1991, what is the difference between the Value added (current US$) of Services and Value added (current US$) of Agriculture?
Keep it short and to the point. 9.72e+1. In the year 1992, what is the difference between the Value added (current US$) in Industry and Value added (current US$) in Manufacturing?
Offer a very short reply. 7.47e+1. In the year 1992, what is the difference between the Value added (current US$) of Industry and Value added (current US$) of Services?
Offer a terse response. 4.33e+09. In the year 1992, what is the difference between the Value added (current US$) of Industry and Value added (current US$) of Agriculture?
Your answer should be compact. 1.61e+11. In the year 1992, what is the difference between the Value added (current US$) in Manufacturing and Value added (current US$) in Services?
Offer a terse response. -7.03e+1. In the year 1992, what is the difference between the Value added (current US$) of Manufacturing and Value added (current US$) of Agriculture?
Keep it short and to the point. 8.64e+1. In the year 1992, what is the difference between the Value added (current US$) in Services and Value added (current US$) in Agriculture?
Your response must be concise. 1.57e+11. In the year 1993, what is the difference between the Value added (current US$) of Industry and Value added (current US$) of Manufacturing?
Your answer should be compact. 2.49e+1. In the year 1993, what is the difference between the Value added (current US$) in Industry and Value added (current US$) in Services?
Provide a succinct answer. -4.80e+1. In the year 1993, what is the difference between the Value added (current US$) in Industry and Value added (current US$) in Agriculture?
Provide a succinct answer. 1.43e+11. In the year 1993, what is the difference between the Value added (current US$) of Manufacturing and Value added (current US$) of Services?
Your answer should be compact. -7.29e+1. In the year 1993, what is the difference between the Value added (current US$) in Manufacturing and Value added (current US$) in Agriculture?
Provide a short and direct response. 1.18e+11. In the year 1993, what is the difference between the Value added (current US$) in Services and Value added (current US$) in Agriculture?
Your response must be concise. 1.91e+11. In the year 1994, what is the difference between the Value added (current US$) of Industry and Value added (current US$) of Manufacturing?
Provide a succinct answer. -3.36e+1. In the year 1994, what is the difference between the Value added (current US$) of Industry and Value added (current US$) of Services?
Give a very brief answer. -2.36e+1. In the year 1994, what is the difference between the Value added (current US$) of Industry and Value added (current US$) of Agriculture?
Give a very brief answer. 1.39e+11. In the year 1994, what is the difference between the Value added (current US$) in Manufacturing and Value added (current US$) in Services?
Ensure brevity in your answer.  1.00e+1. In the year 1994, what is the difference between the Value added (current US$) in Manufacturing and Value added (current US$) in Agriculture?
Your answer should be very brief. 1.72e+11. In the year 1994, what is the difference between the Value added (current US$) of Services and Value added (current US$) of Agriculture?
Provide a succinct answer. 1.62e+11. In the year 1995, what is the difference between the Value added (current US$) in Industry and Value added (current US$) in Manufacturing?
Your answer should be compact. -1.11e+11. In the year 1995, what is the difference between the Value added (current US$) of Industry and Value added (current US$) of Services?
Your answer should be compact. -4.05e+1. In the year 1995, what is the difference between the Value added (current US$) in Industry and Value added (current US$) in Agriculture?
Offer a very short reply. 1.10e+11. In the year 1995, what is the difference between the Value added (current US$) of Manufacturing and Value added (current US$) of Services?
Your response must be concise. 7.09e+1. In the year 1995, what is the difference between the Value added (current US$) in Manufacturing and Value added (current US$) in Agriculture?
Your response must be concise. 2.22e+11. In the year 1995, what is the difference between the Value added (current US$) in Services and Value added (current US$) in Agriculture?
Keep it short and to the point. 1.51e+11. In the year 1996, what is the difference between the Value added (current US$) of Industry and Value added (current US$) of Manufacturing?
Provide a succinct answer. -1.92e+1. In the year 1996, what is the difference between the Value added (current US$) of Industry and Value added (current US$) of Services?
Keep it short and to the point. -6.81e+1. In the year 1996, what is the difference between the Value added (current US$) in Industry and Value added (current US$) in Agriculture?
Keep it short and to the point. 1.13e+11. In the year 1996, what is the difference between the Value added (current US$) of Manufacturing and Value added (current US$) of Services?
Provide a short and direct response. -4.89e+1. In the year 1996, what is the difference between the Value added (current US$) in Manufacturing and Value added (current US$) in Agriculture?
Provide a short and direct response. 1.32e+11. In the year 1996, what is the difference between the Value added (current US$) in Services and Value added (current US$) in Agriculture?
Keep it short and to the point. 1.81e+11. In the year 1997, what is the difference between the Value added (current US$) of Industry and Value added (current US$) of Manufacturing?
Offer a very short reply. -5.50e+1. In the year 1997, what is the difference between the Value added (current US$) of Industry and Value added (current US$) of Services?
Keep it short and to the point. -5.31e+1. In the year 1997, what is the difference between the Value added (current US$) of Industry and Value added (current US$) of Agriculture?
Provide a succinct answer. 1.17e+11. In the year 1997, what is the difference between the Value added (current US$) of Manufacturing and Value added (current US$) of Services?
Keep it short and to the point. 1.85e+09. In the year 1997, what is the difference between the Value added (current US$) of Manufacturing and Value added (current US$) of Agriculture?
Provide a succinct answer. 1.72e+11. In the year 1997, what is the difference between the Value added (current US$) in Services and Value added (current US$) in Agriculture?
Provide a succinct answer. 1.70e+11. What is the ratio of the Value added (current US$) in Industry in 1989 to that in 1990?
Make the answer very short. 1.01. What is the ratio of the Value added (current US$) of Manufacturing in 1989 to that in 1990?
Give a very brief answer. 0.84. What is the ratio of the Value added (current US$) in Services in 1989 to that in 1990?
Make the answer very short. 1.21. What is the ratio of the Value added (current US$) in Agriculture in 1989 to that in 1990?
Offer a very short reply. 0.99. What is the ratio of the Value added (current US$) of Manufacturing in 1989 to that in 1991?
Provide a succinct answer. 0.58. What is the ratio of the Value added (current US$) of Services in 1989 to that in 1991?
Provide a succinct answer. 1.12. What is the ratio of the Value added (current US$) in Agriculture in 1989 to that in 1991?
Your answer should be very brief. 1.11. What is the ratio of the Value added (current US$) of Industry in 1989 to that in 1992?
Ensure brevity in your answer.  1.21. What is the ratio of the Value added (current US$) of Manufacturing in 1989 to that in 1992?
Give a very brief answer. 0.44. What is the ratio of the Value added (current US$) in Agriculture in 1989 to that in 1992?
Make the answer very short. 2.36. What is the ratio of the Value added (current US$) in Industry in 1989 to that in 1993?
Offer a very short reply. 1.34. What is the ratio of the Value added (current US$) of Manufacturing in 1989 to that in 1993?
Provide a succinct answer. 0.34. What is the ratio of the Value added (current US$) in Services in 1989 to that in 1993?
Give a very brief answer. 0.84. What is the ratio of the Value added (current US$) in Agriculture in 1989 to that in 1993?
Your response must be concise. 2.4. What is the ratio of the Value added (current US$) in Industry in 1989 to that in 1994?
Provide a short and direct response. 1.45. What is the ratio of the Value added (current US$) in Manufacturing in 1989 to that in 1994?
Your answer should be very brief. 0.27. What is the ratio of the Value added (current US$) of Services in 1989 to that in 1994?
Provide a short and direct response. 1.01. What is the ratio of the Value added (current US$) of Agriculture in 1989 to that in 1994?
Ensure brevity in your answer.  3.27. What is the ratio of the Value added (current US$) of Industry in 1989 to that in 1995?
Your answer should be compact. 1.73. What is the ratio of the Value added (current US$) in Manufacturing in 1989 to that in 1995?
Offer a terse response. 0.21. What is the ratio of the Value added (current US$) of Services in 1989 to that in 1995?
Your answer should be compact. 1.06. What is the ratio of the Value added (current US$) of Agriculture in 1989 to that in 1995?
Ensure brevity in your answer.  2.99. What is the ratio of the Value added (current US$) of Industry in 1989 to that in 1996?
Offer a very short reply. 1.7. What is the ratio of the Value added (current US$) of Manufacturing in 1989 to that in 1996?
Give a very brief answer. 0.33. What is the ratio of the Value added (current US$) in Services in 1989 to that in 1996?
Your answer should be very brief. 0.91. What is the ratio of the Value added (current US$) in Agriculture in 1989 to that in 1996?
Give a very brief answer. 3.08. What is the ratio of the Value added (current US$) of Industry in 1989 to that in 1997?
Your answer should be compact. 1.68. What is the ratio of the Value added (current US$) of Manufacturing in 1989 to that in 1997?
Give a very brief answer. 0.27. What is the ratio of the Value added (current US$) of Services in 1989 to that in 1997?
Your response must be concise. 0.97. What is the ratio of the Value added (current US$) of Agriculture in 1989 to that in 1997?
Make the answer very short. 3.32. What is the ratio of the Value added (current US$) of Manufacturing in 1990 to that in 1991?
Your answer should be very brief. 0.69. What is the ratio of the Value added (current US$) in Services in 1990 to that in 1991?
Your response must be concise. 0.92. What is the ratio of the Value added (current US$) in Agriculture in 1990 to that in 1991?
Offer a terse response. 1.12. What is the ratio of the Value added (current US$) in Industry in 1990 to that in 1992?
Your answer should be very brief. 1.2. What is the ratio of the Value added (current US$) in Manufacturing in 1990 to that in 1992?
Give a very brief answer. 0.52. What is the ratio of the Value added (current US$) of Services in 1990 to that in 1992?
Your answer should be very brief. 0.81. What is the ratio of the Value added (current US$) in Agriculture in 1990 to that in 1992?
Keep it short and to the point. 2.39. What is the ratio of the Value added (current US$) of Industry in 1990 to that in 1993?
Provide a succinct answer. 1.32. What is the ratio of the Value added (current US$) of Manufacturing in 1990 to that in 1993?
Keep it short and to the point. 0.41. What is the ratio of the Value added (current US$) in Services in 1990 to that in 1993?
Ensure brevity in your answer.  0.69. What is the ratio of the Value added (current US$) of Agriculture in 1990 to that in 1993?
Make the answer very short. 2.43. What is the ratio of the Value added (current US$) of Industry in 1990 to that in 1994?
Make the answer very short. 1.43. What is the ratio of the Value added (current US$) in Manufacturing in 1990 to that in 1994?
Your answer should be compact. 0.31. What is the ratio of the Value added (current US$) in Services in 1990 to that in 1994?
Your response must be concise. 0.83. What is the ratio of the Value added (current US$) of Agriculture in 1990 to that in 1994?
Give a very brief answer. 3.31. What is the ratio of the Value added (current US$) of Industry in 1990 to that in 1995?
Give a very brief answer. 1.7. What is the ratio of the Value added (current US$) of Manufacturing in 1990 to that in 1995?
Offer a very short reply. 0.25. What is the ratio of the Value added (current US$) of Services in 1990 to that in 1995?
Ensure brevity in your answer.  0.87. What is the ratio of the Value added (current US$) of Agriculture in 1990 to that in 1995?
Keep it short and to the point. 3.02. What is the ratio of the Value added (current US$) of Industry in 1990 to that in 1996?
Your response must be concise. 1.68. What is the ratio of the Value added (current US$) of Manufacturing in 1990 to that in 1996?
Offer a very short reply. 0.39. What is the ratio of the Value added (current US$) in Services in 1990 to that in 1996?
Ensure brevity in your answer.  0.75. What is the ratio of the Value added (current US$) of Agriculture in 1990 to that in 1996?
Give a very brief answer. 3.11. What is the ratio of the Value added (current US$) in Industry in 1990 to that in 1997?
Your answer should be compact. 1.66. What is the ratio of the Value added (current US$) of Manufacturing in 1990 to that in 1997?
Provide a short and direct response. 0.32. What is the ratio of the Value added (current US$) of Services in 1990 to that in 1997?
Keep it short and to the point. 0.8. What is the ratio of the Value added (current US$) of Agriculture in 1990 to that in 1997?
Make the answer very short. 3.36. What is the ratio of the Value added (current US$) in Industry in 1991 to that in 1992?
Make the answer very short. 1.22. What is the ratio of the Value added (current US$) of Manufacturing in 1991 to that in 1992?
Offer a very short reply. 0.75. What is the ratio of the Value added (current US$) of Services in 1991 to that in 1992?
Keep it short and to the point. 0.89. What is the ratio of the Value added (current US$) of Agriculture in 1991 to that in 1992?
Provide a succinct answer. 2.13. What is the ratio of the Value added (current US$) of Industry in 1991 to that in 1993?
Your answer should be very brief. 1.35. What is the ratio of the Value added (current US$) in Manufacturing in 1991 to that in 1993?
Offer a very short reply. 0.59. What is the ratio of the Value added (current US$) in Services in 1991 to that in 1993?
Your response must be concise. 0.75. What is the ratio of the Value added (current US$) of Agriculture in 1991 to that in 1993?
Your answer should be compact. 2.17. What is the ratio of the Value added (current US$) in Industry in 1991 to that in 1994?
Keep it short and to the point. 1.46. What is the ratio of the Value added (current US$) of Manufacturing in 1991 to that in 1994?
Give a very brief answer. 0.46. What is the ratio of the Value added (current US$) of Services in 1991 to that in 1994?
Make the answer very short. 0.9. What is the ratio of the Value added (current US$) of Agriculture in 1991 to that in 1994?
Offer a very short reply. 2.96. What is the ratio of the Value added (current US$) of Industry in 1991 to that in 1995?
Keep it short and to the point. 1.74. What is the ratio of the Value added (current US$) in Manufacturing in 1991 to that in 1995?
Offer a very short reply. 0.36. What is the ratio of the Value added (current US$) of Services in 1991 to that in 1995?
Your answer should be compact. 0.95. What is the ratio of the Value added (current US$) of Agriculture in 1991 to that in 1995?
Give a very brief answer. 2.69. What is the ratio of the Value added (current US$) in Industry in 1991 to that in 1996?
Your answer should be compact. 1.72. What is the ratio of the Value added (current US$) of Manufacturing in 1991 to that in 1996?
Keep it short and to the point. 0.57. What is the ratio of the Value added (current US$) in Services in 1991 to that in 1996?
Your response must be concise. 0.82. What is the ratio of the Value added (current US$) in Agriculture in 1991 to that in 1996?
Give a very brief answer. 2.78. What is the ratio of the Value added (current US$) in Industry in 1991 to that in 1997?
Your answer should be very brief. 1.69. What is the ratio of the Value added (current US$) in Manufacturing in 1991 to that in 1997?
Your response must be concise. 0.46. What is the ratio of the Value added (current US$) of Services in 1991 to that in 1997?
Provide a succinct answer. 0.87. What is the ratio of the Value added (current US$) of Agriculture in 1991 to that in 1997?
Provide a short and direct response. 3. What is the ratio of the Value added (current US$) in Industry in 1992 to that in 1993?
Your answer should be compact. 1.1. What is the ratio of the Value added (current US$) of Manufacturing in 1992 to that in 1993?
Provide a succinct answer. 0.79. What is the ratio of the Value added (current US$) in Services in 1992 to that in 1993?
Your answer should be compact. 0.85. What is the ratio of the Value added (current US$) in Agriculture in 1992 to that in 1993?
Ensure brevity in your answer.  1.02. What is the ratio of the Value added (current US$) of Industry in 1992 to that in 1994?
Offer a terse response. 1.19. What is the ratio of the Value added (current US$) of Manufacturing in 1992 to that in 1994?
Keep it short and to the point. 0.61. What is the ratio of the Value added (current US$) in Agriculture in 1992 to that in 1994?
Keep it short and to the point. 1.39. What is the ratio of the Value added (current US$) of Industry in 1992 to that in 1995?
Give a very brief answer. 1.42. What is the ratio of the Value added (current US$) of Manufacturing in 1992 to that in 1995?
Provide a short and direct response. 0.48. What is the ratio of the Value added (current US$) in Services in 1992 to that in 1995?
Keep it short and to the point. 1.07. What is the ratio of the Value added (current US$) of Agriculture in 1992 to that in 1995?
Your answer should be compact. 1.26. What is the ratio of the Value added (current US$) of Industry in 1992 to that in 1996?
Keep it short and to the point. 1.4. What is the ratio of the Value added (current US$) in Manufacturing in 1992 to that in 1996?
Provide a short and direct response. 0.76. What is the ratio of the Value added (current US$) of Services in 1992 to that in 1996?
Your response must be concise. 0.92. What is the ratio of the Value added (current US$) of Agriculture in 1992 to that in 1996?
Your answer should be compact. 1.3. What is the ratio of the Value added (current US$) in Industry in 1992 to that in 1997?
Keep it short and to the point. 1.38. What is the ratio of the Value added (current US$) in Manufacturing in 1992 to that in 1997?
Offer a terse response. 0.61. What is the ratio of the Value added (current US$) of Services in 1992 to that in 1997?
Your answer should be very brief. 0.98. What is the ratio of the Value added (current US$) in Agriculture in 1992 to that in 1997?
Your answer should be compact. 1.41. What is the ratio of the Value added (current US$) in Industry in 1993 to that in 1994?
Give a very brief answer. 1.08. What is the ratio of the Value added (current US$) in Manufacturing in 1993 to that in 1994?
Make the answer very short. 0.77. What is the ratio of the Value added (current US$) of Services in 1993 to that in 1994?
Keep it short and to the point. 1.2. What is the ratio of the Value added (current US$) of Agriculture in 1993 to that in 1994?
Provide a succinct answer. 1.36. What is the ratio of the Value added (current US$) in Industry in 1993 to that in 1995?
Offer a very short reply. 1.29. What is the ratio of the Value added (current US$) of Manufacturing in 1993 to that in 1995?
Your answer should be very brief. 0.61. What is the ratio of the Value added (current US$) in Services in 1993 to that in 1995?
Offer a very short reply. 1.27. What is the ratio of the Value added (current US$) of Agriculture in 1993 to that in 1995?
Offer a terse response. 1.24. What is the ratio of the Value added (current US$) of Industry in 1993 to that in 1996?
Your answer should be compact. 1.27. What is the ratio of the Value added (current US$) of Manufacturing in 1993 to that in 1996?
Offer a very short reply. 0.96. What is the ratio of the Value added (current US$) of Services in 1993 to that in 1996?
Offer a terse response. 1.09. What is the ratio of the Value added (current US$) of Agriculture in 1993 to that in 1996?
Your answer should be very brief. 1.28. What is the ratio of the Value added (current US$) in Industry in 1993 to that in 1997?
Keep it short and to the point. 1.26. What is the ratio of the Value added (current US$) in Manufacturing in 1993 to that in 1997?
Offer a very short reply. 0.77. What is the ratio of the Value added (current US$) of Services in 1993 to that in 1997?
Make the answer very short. 1.16. What is the ratio of the Value added (current US$) of Agriculture in 1993 to that in 1997?
Your answer should be very brief. 1.38. What is the ratio of the Value added (current US$) of Industry in 1994 to that in 1995?
Give a very brief answer. 1.19. What is the ratio of the Value added (current US$) of Manufacturing in 1994 to that in 1995?
Provide a short and direct response. 0.79. What is the ratio of the Value added (current US$) in Services in 1994 to that in 1995?
Make the answer very short. 1.05. What is the ratio of the Value added (current US$) in Agriculture in 1994 to that in 1995?
Your answer should be compact. 0.91. What is the ratio of the Value added (current US$) in Industry in 1994 to that in 1996?
Keep it short and to the point. 1.18. What is the ratio of the Value added (current US$) in Manufacturing in 1994 to that in 1996?
Your answer should be compact. 1.25. What is the ratio of the Value added (current US$) in Services in 1994 to that in 1996?
Give a very brief answer. 0.9. What is the ratio of the Value added (current US$) in Agriculture in 1994 to that in 1996?
Make the answer very short. 0.94. What is the ratio of the Value added (current US$) in Industry in 1994 to that in 1997?
Make the answer very short. 1.16. What is the ratio of the Value added (current US$) of Manufacturing in 1994 to that in 1997?
Provide a succinct answer. 1.01. What is the ratio of the Value added (current US$) of Agriculture in 1994 to that in 1997?
Offer a very short reply. 1.02. What is the ratio of the Value added (current US$) in Industry in 1995 to that in 1996?
Your answer should be very brief. 0.99. What is the ratio of the Value added (current US$) in Manufacturing in 1995 to that in 1996?
Offer a very short reply. 1.57. What is the ratio of the Value added (current US$) of Services in 1995 to that in 1996?
Give a very brief answer. 0.86. What is the ratio of the Value added (current US$) of Agriculture in 1995 to that in 1996?
Your response must be concise. 1.03. What is the ratio of the Value added (current US$) in Industry in 1995 to that in 1997?
Ensure brevity in your answer.  0.97. What is the ratio of the Value added (current US$) in Manufacturing in 1995 to that in 1997?
Your answer should be compact. 1.27. What is the ratio of the Value added (current US$) in Services in 1995 to that in 1997?
Provide a succinct answer. 0.92. What is the ratio of the Value added (current US$) in Agriculture in 1995 to that in 1997?
Give a very brief answer. 1.11. What is the ratio of the Value added (current US$) of Industry in 1996 to that in 1997?
Keep it short and to the point. 0.99. What is the ratio of the Value added (current US$) of Manufacturing in 1996 to that in 1997?
Offer a terse response. 0.81. What is the ratio of the Value added (current US$) of Services in 1996 to that in 1997?
Ensure brevity in your answer.  1.07. What is the ratio of the Value added (current US$) of Agriculture in 1996 to that in 1997?
Offer a very short reply. 1.08. What is the difference between the highest and the second highest Value added (current US$) in Industry?
Give a very brief answer. 1.55e+09. What is the difference between the highest and the second highest Value added (current US$) of Manufacturing?
Offer a very short reply. 5.16e+1. What is the difference between the highest and the second highest Value added (current US$) of Services?
Your response must be concise. 1.77e+1. What is the difference between the highest and the second highest Value added (current US$) in Agriculture?
Provide a short and direct response. 8.80e+08. What is the difference between the highest and the lowest Value added (current US$) of Industry?
Provide a short and direct response. 1.01e+11. What is the difference between the highest and the lowest Value added (current US$) in Manufacturing?
Provide a succinct answer. 1.96e+11. What is the difference between the highest and the lowest Value added (current US$) in Services?
Give a very brief answer. 6.93e+1. What is the difference between the highest and the lowest Value added (current US$) in Agriculture?
Give a very brief answer. 5.61e+1. 